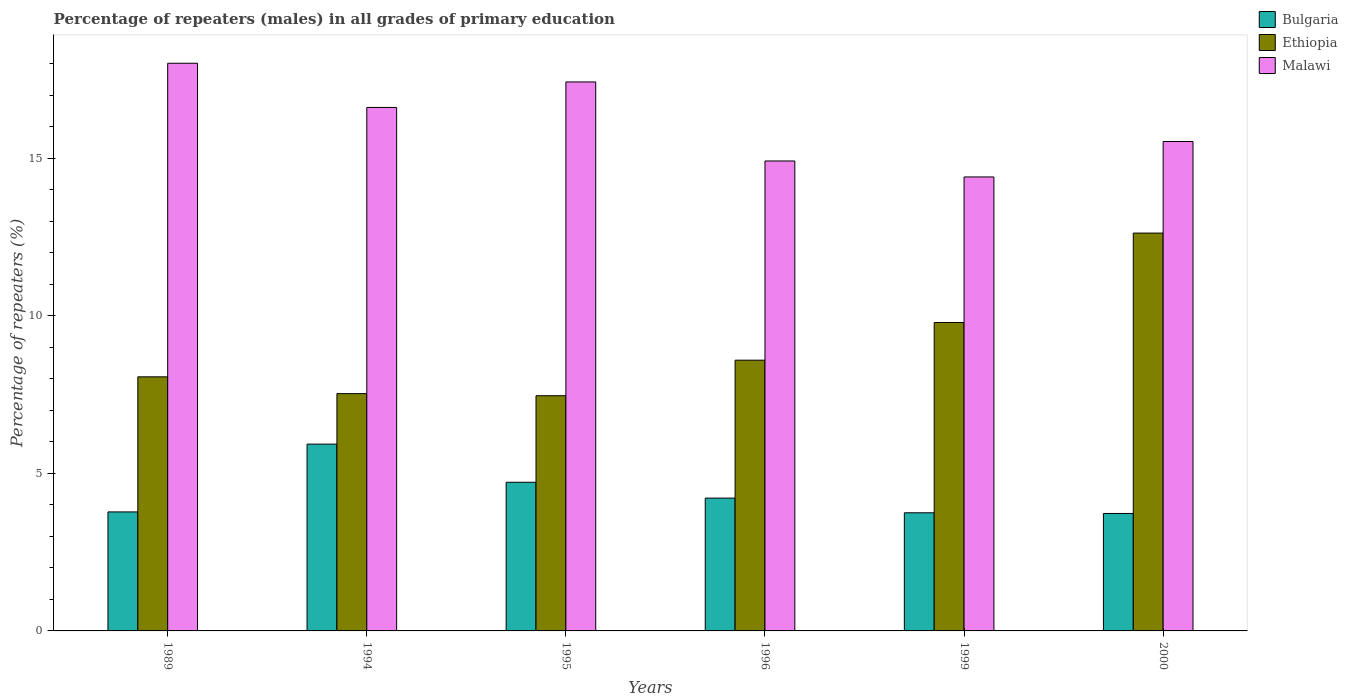Are the number of bars on each tick of the X-axis equal?
Offer a terse response. Yes. How many bars are there on the 1st tick from the right?
Keep it short and to the point. 3. What is the label of the 5th group of bars from the left?
Ensure brevity in your answer.  1999. In how many cases, is the number of bars for a given year not equal to the number of legend labels?
Ensure brevity in your answer.  0. What is the percentage of repeaters (males) in Bulgaria in 1996?
Offer a very short reply. 4.22. Across all years, what is the maximum percentage of repeaters (males) in Bulgaria?
Ensure brevity in your answer.  5.93. Across all years, what is the minimum percentage of repeaters (males) in Bulgaria?
Keep it short and to the point. 3.73. In which year was the percentage of repeaters (males) in Malawi maximum?
Your response must be concise. 1989. In which year was the percentage of repeaters (males) in Ethiopia minimum?
Offer a very short reply. 1995. What is the total percentage of repeaters (males) in Ethiopia in the graph?
Provide a short and direct response. 54.07. What is the difference between the percentage of repeaters (males) in Malawi in 1995 and that in 2000?
Provide a short and direct response. 1.89. What is the difference between the percentage of repeaters (males) in Malawi in 1999 and the percentage of repeaters (males) in Bulgaria in 1994?
Your answer should be very brief. 8.48. What is the average percentage of repeaters (males) in Bulgaria per year?
Offer a very short reply. 4.35. In the year 1996, what is the difference between the percentage of repeaters (males) in Malawi and percentage of repeaters (males) in Bulgaria?
Offer a terse response. 10.7. In how many years, is the percentage of repeaters (males) in Malawi greater than 1 %?
Provide a succinct answer. 6. What is the ratio of the percentage of repeaters (males) in Ethiopia in 1996 to that in 1999?
Your answer should be compact. 0.88. Is the difference between the percentage of repeaters (males) in Malawi in 1989 and 2000 greater than the difference between the percentage of repeaters (males) in Bulgaria in 1989 and 2000?
Provide a succinct answer. Yes. What is the difference between the highest and the second highest percentage of repeaters (males) in Ethiopia?
Keep it short and to the point. 2.84. What is the difference between the highest and the lowest percentage of repeaters (males) in Malawi?
Keep it short and to the point. 3.61. In how many years, is the percentage of repeaters (males) in Malawi greater than the average percentage of repeaters (males) in Malawi taken over all years?
Ensure brevity in your answer.  3. Is the sum of the percentage of repeaters (males) in Ethiopia in 1989 and 1999 greater than the maximum percentage of repeaters (males) in Malawi across all years?
Give a very brief answer. No. What does the 3rd bar from the left in 1999 represents?
Your response must be concise. Malawi. What does the 3rd bar from the right in 1995 represents?
Offer a terse response. Bulgaria. How many bars are there?
Offer a terse response. 18. How many years are there in the graph?
Your answer should be very brief. 6. What is the difference between two consecutive major ticks on the Y-axis?
Your answer should be very brief. 5. Are the values on the major ticks of Y-axis written in scientific E-notation?
Provide a succinct answer. No. Does the graph contain grids?
Ensure brevity in your answer.  No. Where does the legend appear in the graph?
Provide a short and direct response. Top right. How are the legend labels stacked?
Provide a succinct answer. Vertical. What is the title of the graph?
Provide a succinct answer. Percentage of repeaters (males) in all grades of primary education. What is the label or title of the Y-axis?
Your answer should be very brief. Percentage of repeaters (%). What is the Percentage of repeaters (%) in Bulgaria in 1989?
Offer a very short reply. 3.78. What is the Percentage of repeaters (%) of Ethiopia in 1989?
Offer a very short reply. 8.07. What is the Percentage of repeaters (%) in Malawi in 1989?
Your answer should be compact. 18.02. What is the Percentage of repeaters (%) of Bulgaria in 1994?
Your answer should be compact. 5.93. What is the Percentage of repeaters (%) in Ethiopia in 1994?
Ensure brevity in your answer.  7.53. What is the Percentage of repeaters (%) in Malawi in 1994?
Your answer should be very brief. 16.62. What is the Percentage of repeaters (%) in Bulgaria in 1995?
Provide a short and direct response. 4.72. What is the Percentage of repeaters (%) in Ethiopia in 1995?
Ensure brevity in your answer.  7.47. What is the Percentage of repeaters (%) in Malawi in 1995?
Make the answer very short. 17.43. What is the Percentage of repeaters (%) of Bulgaria in 1996?
Keep it short and to the point. 4.22. What is the Percentage of repeaters (%) of Ethiopia in 1996?
Provide a succinct answer. 8.59. What is the Percentage of repeaters (%) of Malawi in 1996?
Offer a terse response. 14.92. What is the Percentage of repeaters (%) in Bulgaria in 1999?
Make the answer very short. 3.75. What is the Percentage of repeaters (%) of Ethiopia in 1999?
Keep it short and to the point. 9.79. What is the Percentage of repeaters (%) in Malawi in 1999?
Make the answer very short. 14.41. What is the Percentage of repeaters (%) in Bulgaria in 2000?
Your answer should be compact. 3.73. What is the Percentage of repeaters (%) of Ethiopia in 2000?
Keep it short and to the point. 12.63. What is the Percentage of repeaters (%) of Malawi in 2000?
Your response must be concise. 15.53. Across all years, what is the maximum Percentage of repeaters (%) in Bulgaria?
Provide a short and direct response. 5.93. Across all years, what is the maximum Percentage of repeaters (%) in Ethiopia?
Provide a succinct answer. 12.63. Across all years, what is the maximum Percentage of repeaters (%) of Malawi?
Provide a succinct answer. 18.02. Across all years, what is the minimum Percentage of repeaters (%) in Bulgaria?
Ensure brevity in your answer.  3.73. Across all years, what is the minimum Percentage of repeaters (%) in Ethiopia?
Give a very brief answer. 7.47. Across all years, what is the minimum Percentage of repeaters (%) of Malawi?
Keep it short and to the point. 14.41. What is the total Percentage of repeaters (%) of Bulgaria in the graph?
Offer a terse response. 26.12. What is the total Percentage of repeaters (%) in Ethiopia in the graph?
Provide a succinct answer. 54.07. What is the total Percentage of repeaters (%) in Malawi in the graph?
Provide a short and direct response. 96.92. What is the difference between the Percentage of repeaters (%) in Bulgaria in 1989 and that in 1994?
Give a very brief answer. -2.15. What is the difference between the Percentage of repeaters (%) of Ethiopia in 1989 and that in 1994?
Your answer should be compact. 0.53. What is the difference between the Percentage of repeaters (%) in Malawi in 1989 and that in 1994?
Offer a terse response. 1.4. What is the difference between the Percentage of repeaters (%) of Bulgaria in 1989 and that in 1995?
Make the answer very short. -0.94. What is the difference between the Percentage of repeaters (%) of Ethiopia in 1989 and that in 1995?
Provide a succinct answer. 0.6. What is the difference between the Percentage of repeaters (%) of Malawi in 1989 and that in 1995?
Your response must be concise. 0.59. What is the difference between the Percentage of repeaters (%) in Bulgaria in 1989 and that in 1996?
Your answer should be very brief. -0.44. What is the difference between the Percentage of repeaters (%) of Ethiopia in 1989 and that in 1996?
Your answer should be very brief. -0.53. What is the difference between the Percentage of repeaters (%) in Malawi in 1989 and that in 1996?
Your answer should be compact. 3.1. What is the difference between the Percentage of repeaters (%) of Bulgaria in 1989 and that in 1999?
Give a very brief answer. 0.03. What is the difference between the Percentage of repeaters (%) of Ethiopia in 1989 and that in 1999?
Provide a succinct answer. -1.72. What is the difference between the Percentage of repeaters (%) of Malawi in 1989 and that in 1999?
Ensure brevity in your answer.  3.61. What is the difference between the Percentage of repeaters (%) of Bulgaria in 1989 and that in 2000?
Your response must be concise. 0.05. What is the difference between the Percentage of repeaters (%) of Ethiopia in 1989 and that in 2000?
Provide a succinct answer. -4.56. What is the difference between the Percentage of repeaters (%) of Malawi in 1989 and that in 2000?
Offer a very short reply. 2.48. What is the difference between the Percentage of repeaters (%) of Bulgaria in 1994 and that in 1995?
Keep it short and to the point. 1.21. What is the difference between the Percentage of repeaters (%) in Ethiopia in 1994 and that in 1995?
Give a very brief answer. 0.07. What is the difference between the Percentage of repeaters (%) of Malawi in 1994 and that in 1995?
Provide a succinct answer. -0.81. What is the difference between the Percentage of repeaters (%) of Bulgaria in 1994 and that in 1996?
Your response must be concise. 1.71. What is the difference between the Percentage of repeaters (%) of Ethiopia in 1994 and that in 1996?
Make the answer very short. -1.06. What is the difference between the Percentage of repeaters (%) of Malawi in 1994 and that in 1996?
Ensure brevity in your answer.  1.7. What is the difference between the Percentage of repeaters (%) in Bulgaria in 1994 and that in 1999?
Your answer should be compact. 2.18. What is the difference between the Percentage of repeaters (%) of Ethiopia in 1994 and that in 1999?
Make the answer very short. -2.26. What is the difference between the Percentage of repeaters (%) of Malawi in 1994 and that in 1999?
Your response must be concise. 2.21. What is the difference between the Percentage of repeaters (%) of Bulgaria in 1994 and that in 2000?
Offer a very short reply. 2.2. What is the difference between the Percentage of repeaters (%) in Ethiopia in 1994 and that in 2000?
Keep it short and to the point. -5.1. What is the difference between the Percentage of repeaters (%) in Malawi in 1994 and that in 2000?
Give a very brief answer. 1.08. What is the difference between the Percentage of repeaters (%) of Bulgaria in 1995 and that in 1996?
Keep it short and to the point. 0.5. What is the difference between the Percentage of repeaters (%) in Ethiopia in 1995 and that in 1996?
Provide a short and direct response. -1.13. What is the difference between the Percentage of repeaters (%) in Malawi in 1995 and that in 1996?
Provide a short and direct response. 2.51. What is the difference between the Percentage of repeaters (%) of Bulgaria in 1995 and that in 1999?
Provide a succinct answer. 0.97. What is the difference between the Percentage of repeaters (%) in Ethiopia in 1995 and that in 1999?
Offer a terse response. -2.32. What is the difference between the Percentage of repeaters (%) of Malawi in 1995 and that in 1999?
Your response must be concise. 3.02. What is the difference between the Percentage of repeaters (%) of Bulgaria in 1995 and that in 2000?
Make the answer very short. 0.99. What is the difference between the Percentage of repeaters (%) of Ethiopia in 1995 and that in 2000?
Your answer should be compact. -5.16. What is the difference between the Percentage of repeaters (%) in Malawi in 1995 and that in 2000?
Offer a terse response. 1.89. What is the difference between the Percentage of repeaters (%) of Bulgaria in 1996 and that in 1999?
Your answer should be very brief. 0.47. What is the difference between the Percentage of repeaters (%) of Ethiopia in 1996 and that in 1999?
Offer a terse response. -1.2. What is the difference between the Percentage of repeaters (%) in Malawi in 1996 and that in 1999?
Your answer should be very brief. 0.51. What is the difference between the Percentage of repeaters (%) of Bulgaria in 1996 and that in 2000?
Your answer should be very brief. 0.49. What is the difference between the Percentage of repeaters (%) of Ethiopia in 1996 and that in 2000?
Provide a short and direct response. -4.03. What is the difference between the Percentage of repeaters (%) of Malawi in 1996 and that in 2000?
Make the answer very short. -0.62. What is the difference between the Percentage of repeaters (%) of Bulgaria in 1999 and that in 2000?
Your response must be concise. 0.02. What is the difference between the Percentage of repeaters (%) in Ethiopia in 1999 and that in 2000?
Offer a very short reply. -2.84. What is the difference between the Percentage of repeaters (%) of Malawi in 1999 and that in 2000?
Give a very brief answer. -1.12. What is the difference between the Percentage of repeaters (%) of Bulgaria in 1989 and the Percentage of repeaters (%) of Ethiopia in 1994?
Your answer should be very brief. -3.75. What is the difference between the Percentage of repeaters (%) of Bulgaria in 1989 and the Percentage of repeaters (%) of Malawi in 1994?
Make the answer very short. -12.84. What is the difference between the Percentage of repeaters (%) in Ethiopia in 1989 and the Percentage of repeaters (%) in Malawi in 1994?
Keep it short and to the point. -8.55. What is the difference between the Percentage of repeaters (%) of Bulgaria in 1989 and the Percentage of repeaters (%) of Ethiopia in 1995?
Provide a short and direct response. -3.69. What is the difference between the Percentage of repeaters (%) of Bulgaria in 1989 and the Percentage of repeaters (%) of Malawi in 1995?
Offer a very short reply. -13.65. What is the difference between the Percentage of repeaters (%) of Ethiopia in 1989 and the Percentage of repeaters (%) of Malawi in 1995?
Give a very brief answer. -9.36. What is the difference between the Percentage of repeaters (%) in Bulgaria in 1989 and the Percentage of repeaters (%) in Ethiopia in 1996?
Provide a short and direct response. -4.82. What is the difference between the Percentage of repeaters (%) in Bulgaria in 1989 and the Percentage of repeaters (%) in Malawi in 1996?
Provide a short and direct response. -11.14. What is the difference between the Percentage of repeaters (%) of Ethiopia in 1989 and the Percentage of repeaters (%) of Malawi in 1996?
Offer a very short reply. -6.85. What is the difference between the Percentage of repeaters (%) in Bulgaria in 1989 and the Percentage of repeaters (%) in Ethiopia in 1999?
Offer a terse response. -6.01. What is the difference between the Percentage of repeaters (%) in Bulgaria in 1989 and the Percentage of repeaters (%) in Malawi in 1999?
Give a very brief answer. -10.63. What is the difference between the Percentage of repeaters (%) in Ethiopia in 1989 and the Percentage of repeaters (%) in Malawi in 1999?
Ensure brevity in your answer.  -6.34. What is the difference between the Percentage of repeaters (%) of Bulgaria in 1989 and the Percentage of repeaters (%) of Ethiopia in 2000?
Offer a terse response. -8.85. What is the difference between the Percentage of repeaters (%) in Bulgaria in 1989 and the Percentage of repeaters (%) in Malawi in 2000?
Offer a terse response. -11.76. What is the difference between the Percentage of repeaters (%) in Ethiopia in 1989 and the Percentage of repeaters (%) in Malawi in 2000?
Offer a terse response. -7.47. What is the difference between the Percentage of repeaters (%) of Bulgaria in 1994 and the Percentage of repeaters (%) of Ethiopia in 1995?
Provide a short and direct response. -1.54. What is the difference between the Percentage of repeaters (%) of Bulgaria in 1994 and the Percentage of repeaters (%) of Malawi in 1995?
Give a very brief answer. -11.5. What is the difference between the Percentage of repeaters (%) of Ethiopia in 1994 and the Percentage of repeaters (%) of Malawi in 1995?
Provide a short and direct response. -9.89. What is the difference between the Percentage of repeaters (%) in Bulgaria in 1994 and the Percentage of repeaters (%) in Ethiopia in 1996?
Your answer should be very brief. -2.66. What is the difference between the Percentage of repeaters (%) of Bulgaria in 1994 and the Percentage of repeaters (%) of Malawi in 1996?
Your response must be concise. -8.99. What is the difference between the Percentage of repeaters (%) in Ethiopia in 1994 and the Percentage of repeaters (%) in Malawi in 1996?
Offer a very short reply. -7.38. What is the difference between the Percentage of repeaters (%) of Bulgaria in 1994 and the Percentage of repeaters (%) of Ethiopia in 1999?
Offer a terse response. -3.86. What is the difference between the Percentage of repeaters (%) in Bulgaria in 1994 and the Percentage of repeaters (%) in Malawi in 1999?
Provide a succinct answer. -8.48. What is the difference between the Percentage of repeaters (%) of Ethiopia in 1994 and the Percentage of repeaters (%) of Malawi in 1999?
Keep it short and to the point. -6.88. What is the difference between the Percentage of repeaters (%) in Bulgaria in 1994 and the Percentage of repeaters (%) in Ethiopia in 2000?
Provide a short and direct response. -6.7. What is the difference between the Percentage of repeaters (%) of Bulgaria in 1994 and the Percentage of repeaters (%) of Malawi in 2000?
Offer a terse response. -9.61. What is the difference between the Percentage of repeaters (%) of Ethiopia in 1994 and the Percentage of repeaters (%) of Malawi in 2000?
Provide a succinct answer. -8. What is the difference between the Percentage of repeaters (%) in Bulgaria in 1995 and the Percentage of repeaters (%) in Ethiopia in 1996?
Your answer should be very brief. -3.87. What is the difference between the Percentage of repeaters (%) of Bulgaria in 1995 and the Percentage of repeaters (%) of Malawi in 1996?
Give a very brief answer. -10.2. What is the difference between the Percentage of repeaters (%) of Ethiopia in 1995 and the Percentage of repeaters (%) of Malawi in 1996?
Give a very brief answer. -7.45. What is the difference between the Percentage of repeaters (%) in Bulgaria in 1995 and the Percentage of repeaters (%) in Ethiopia in 1999?
Offer a terse response. -5.07. What is the difference between the Percentage of repeaters (%) in Bulgaria in 1995 and the Percentage of repeaters (%) in Malawi in 1999?
Your response must be concise. -9.69. What is the difference between the Percentage of repeaters (%) of Ethiopia in 1995 and the Percentage of repeaters (%) of Malawi in 1999?
Give a very brief answer. -6.94. What is the difference between the Percentage of repeaters (%) in Bulgaria in 1995 and the Percentage of repeaters (%) in Ethiopia in 2000?
Ensure brevity in your answer.  -7.91. What is the difference between the Percentage of repeaters (%) of Bulgaria in 1995 and the Percentage of repeaters (%) of Malawi in 2000?
Give a very brief answer. -10.82. What is the difference between the Percentage of repeaters (%) in Ethiopia in 1995 and the Percentage of repeaters (%) in Malawi in 2000?
Your answer should be compact. -8.07. What is the difference between the Percentage of repeaters (%) of Bulgaria in 1996 and the Percentage of repeaters (%) of Ethiopia in 1999?
Give a very brief answer. -5.57. What is the difference between the Percentage of repeaters (%) in Bulgaria in 1996 and the Percentage of repeaters (%) in Malawi in 1999?
Ensure brevity in your answer.  -10.19. What is the difference between the Percentage of repeaters (%) of Ethiopia in 1996 and the Percentage of repeaters (%) of Malawi in 1999?
Offer a terse response. -5.82. What is the difference between the Percentage of repeaters (%) in Bulgaria in 1996 and the Percentage of repeaters (%) in Ethiopia in 2000?
Keep it short and to the point. -8.41. What is the difference between the Percentage of repeaters (%) in Bulgaria in 1996 and the Percentage of repeaters (%) in Malawi in 2000?
Make the answer very short. -11.32. What is the difference between the Percentage of repeaters (%) in Ethiopia in 1996 and the Percentage of repeaters (%) in Malawi in 2000?
Provide a succinct answer. -6.94. What is the difference between the Percentage of repeaters (%) in Bulgaria in 1999 and the Percentage of repeaters (%) in Ethiopia in 2000?
Your response must be concise. -8.88. What is the difference between the Percentage of repeaters (%) in Bulgaria in 1999 and the Percentage of repeaters (%) in Malawi in 2000?
Provide a succinct answer. -11.78. What is the difference between the Percentage of repeaters (%) in Ethiopia in 1999 and the Percentage of repeaters (%) in Malawi in 2000?
Your response must be concise. -5.75. What is the average Percentage of repeaters (%) in Bulgaria per year?
Ensure brevity in your answer.  4.35. What is the average Percentage of repeaters (%) in Ethiopia per year?
Provide a succinct answer. 9.01. What is the average Percentage of repeaters (%) of Malawi per year?
Offer a terse response. 16.15. In the year 1989, what is the difference between the Percentage of repeaters (%) of Bulgaria and Percentage of repeaters (%) of Ethiopia?
Offer a terse response. -4.29. In the year 1989, what is the difference between the Percentage of repeaters (%) in Bulgaria and Percentage of repeaters (%) in Malawi?
Provide a succinct answer. -14.24. In the year 1989, what is the difference between the Percentage of repeaters (%) of Ethiopia and Percentage of repeaters (%) of Malawi?
Give a very brief answer. -9.95. In the year 1994, what is the difference between the Percentage of repeaters (%) in Bulgaria and Percentage of repeaters (%) in Ethiopia?
Your response must be concise. -1.6. In the year 1994, what is the difference between the Percentage of repeaters (%) in Bulgaria and Percentage of repeaters (%) in Malawi?
Your answer should be very brief. -10.69. In the year 1994, what is the difference between the Percentage of repeaters (%) of Ethiopia and Percentage of repeaters (%) of Malawi?
Your answer should be compact. -9.08. In the year 1995, what is the difference between the Percentage of repeaters (%) of Bulgaria and Percentage of repeaters (%) of Ethiopia?
Your response must be concise. -2.75. In the year 1995, what is the difference between the Percentage of repeaters (%) of Bulgaria and Percentage of repeaters (%) of Malawi?
Keep it short and to the point. -12.71. In the year 1995, what is the difference between the Percentage of repeaters (%) of Ethiopia and Percentage of repeaters (%) of Malawi?
Ensure brevity in your answer.  -9.96. In the year 1996, what is the difference between the Percentage of repeaters (%) of Bulgaria and Percentage of repeaters (%) of Ethiopia?
Make the answer very short. -4.38. In the year 1996, what is the difference between the Percentage of repeaters (%) of Bulgaria and Percentage of repeaters (%) of Malawi?
Your answer should be compact. -10.7. In the year 1996, what is the difference between the Percentage of repeaters (%) in Ethiopia and Percentage of repeaters (%) in Malawi?
Keep it short and to the point. -6.32. In the year 1999, what is the difference between the Percentage of repeaters (%) of Bulgaria and Percentage of repeaters (%) of Ethiopia?
Offer a terse response. -6.04. In the year 1999, what is the difference between the Percentage of repeaters (%) of Bulgaria and Percentage of repeaters (%) of Malawi?
Your answer should be compact. -10.66. In the year 1999, what is the difference between the Percentage of repeaters (%) in Ethiopia and Percentage of repeaters (%) in Malawi?
Your response must be concise. -4.62. In the year 2000, what is the difference between the Percentage of repeaters (%) in Bulgaria and Percentage of repeaters (%) in Ethiopia?
Offer a terse response. -8.9. In the year 2000, what is the difference between the Percentage of repeaters (%) in Bulgaria and Percentage of repeaters (%) in Malawi?
Offer a terse response. -11.81. In the year 2000, what is the difference between the Percentage of repeaters (%) of Ethiopia and Percentage of repeaters (%) of Malawi?
Provide a short and direct response. -2.91. What is the ratio of the Percentage of repeaters (%) in Bulgaria in 1989 to that in 1994?
Your response must be concise. 0.64. What is the ratio of the Percentage of repeaters (%) in Ethiopia in 1989 to that in 1994?
Your answer should be compact. 1.07. What is the ratio of the Percentage of repeaters (%) of Malawi in 1989 to that in 1994?
Provide a short and direct response. 1.08. What is the ratio of the Percentage of repeaters (%) of Bulgaria in 1989 to that in 1995?
Your answer should be very brief. 0.8. What is the ratio of the Percentage of repeaters (%) of Ethiopia in 1989 to that in 1995?
Provide a short and direct response. 1.08. What is the ratio of the Percentage of repeaters (%) of Malawi in 1989 to that in 1995?
Make the answer very short. 1.03. What is the ratio of the Percentage of repeaters (%) of Bulgaria in 1989 to that in 1996?
Give a very brief answer. 0.9. What is the ratio of the Percentage of repeaters (%) of Ethiopia in 1989 to that in 1996?
Give a very brief answer. 0.94. What is the ratio of the Percentage of repeaters (%) in Malawi in 1989 to that in 1996?
Ensure brevity in your answer.  1.21. What is the ratio of the Percentage of repeaters (%) of Bulgaria in 1989 to that in 1999?
Keep it short and to the point. 1.01. What is the ratio of the Percentage of repeaters (%) of Ethiopia in 1989 to that in 1999?
Ensure brevity in your answer.  0.82. What is the ratio of the Percentage of repeaters (%) in Malawi in 1989 to that in 1999?
Provide a short and direct response. 1.25. What is the ratio of the Percentage of repeaters (%) of Bulgaria in 1989 to that in 2000?
Keep it short and to the point. 1.01. What is the ratio of the Percentage of repeaters (%) of Ethiopia in 1989 to that in 2000?
Give a very brief answer. 0.64. What is the ratio of the Percentage of repeaters (%) of Malawi in 1989 to that in 2000?
Give a very brief answer. 1.16. What is the ratio of the Percentage of repeaters (%) of Bulgaria in 1994 to that in 1995?
Provide a short and direct response. 1.26. What is the ratio of the Percentage of repeaters (%) in Ethiopia in 1994 to that in 1995?
Provide a succinct answer. 1.01. What is the ratio of the Percentage of repeaters (%) of Malawi in 1994 to that in 1995?
Offer a very short reply. 0.95. What is the ratio of the Percentage of repeaters (%) in Bulgaria in 1994 to that in 1996?
Your answer should be compact. 1.41. What is the ratio of the Percentage of repeaters (%) in Ethiopia in 1994 to that in 1996?
Offer a very short reply. 0.88. What is the ratio of the Percentage of repeaters (%) of Malawi in 1994 to that in 1996?
Provide a short and direct response. 1.11. What is the ratio of the Percentage of repeaters (%) of Bulgaria in 1994 to that in 1999?
Provide a short and direct response. 1.58. What is the ratio of the Percentage of repeaters (%) of Ethiopia in 1994 to that in 1999?
Offer a terse response. 0.77. What is the ratio of the Percentage of repeaters (%) in Malawi in 1994 to that in 1999?
Your answer should be very brief. 1.15. What is the ratio of the Percentage of repeaters (%) in Bulgaria in 1994 to that in 2000?
Keep it short and to the point. 1.59. What is the ratio of the Percentage of repeaters (%) of Ethiopia in 1994 to that in 2000?
Your answer should be compact. 0.6. What is the ratio of the Percentage of repeaters (%) of Malawi in 1994 to that in 2000?
Make the answer very short. 1.07. What is the ratio of the Percentage of repeaters (%) in Bulgaria in 1995 to that in 1996?
Your answer should be very brief. 1.12. What is the ratio of the Percentage of repeaters (%) in Ethiopia in 1995 to that in 1996?
Ensure brevity in your answer.  0.87. What is the ratio of the Percentage of repeaters (%) in Malawi in 1995 to that in 1996?
Ensure brevity in your answer.  1.17. What is the ratio of the Percentage of repeaters (%) of Bulgaria in 1995 to that in 1999?
Give a very brief answer. 1.26. What is the ratio of the Percentage of repeaters (%) of Ethiopia in 1995 to that in 1999?
Your answer should be very brief. 0.76. What is the ratio of the Percentage of repeaters (%) in Malawi in 1995 to that in 1999?
Your answer should be compact. 1.21. What is the ratio of the Percentage of repeaters (%) of Bulgaria in 1995 to that in 2000?
Give a very brief answer. 1.27. What is the ratio of the Percentage of repeaters (%) in Ethiopia in 1995 to that in 2000?
Offer a terse response. 0.59. What is the ratio of the Percentage of repeaters (%) of Malawi in 1995 to that in 2000?
Your response must be concise. 1.12. What is the ratio of the Percentage of repeaters (%) in Bulgaria in 1996 to that in 1999?
Keep it short and to the point. 1.12. What is the ratio of the Percentage of repeaters (%) in Ethiopia in 1996 to that in 1999?
Offer a very short reply. 0.88. What is the ratio of the Percentage of repeaters (%) of Malawi in 1996 to that in 1999?
Make the answer very short. 1.04. What is the ratio of the Percentage of repeaters (%) of Bulgaria in 1996 to that in 2000?
Your answer should be very brief. 1.13. What is the ratio of the Percentage of repeaters (%) in Ethiopia in 1996 to that in 2000?
Provide a short and direct response. 0.68. What is the ratio of the Percentage of repeaters (%) in Malawi in 1996 to that in 2000?
Your answer should be very brief. 0.96. What is the ratio of the Percentage of repeaters (%) of Bulgaria in 1999 to that in 2000?
Your response must be concise. 1.01. What is the ratio of the Percentage of repeaters (%) in Ethiopia in 1999 to that in 2000?
Your response must be concise. 0.78. What is the ratio of the Percentage of repeaters (%) in Malawi in 1999 to that in 2000?
Your response must be concise. 0.93. What is the difference between the highest and the second highest Percentage of repeaters (%) of Bulgaria?
Give a very brief answer. 1.21. What is the difference between the highest and the second highest Percentage of repeaters (%) of Ethiopia?
Keep it short and to the point. 2.84. What is the difference between the highest and the second highest Percentage of repeaters (%) in Malawi?
Offer a terse response. 0.59. What is the difference between the highest and the lowest Percentage of repeaters (%) in Bulgaria?
Provide a short and direct response. 2.2. What is the difference between the highest and the lowest Percentage of repeaters (%) in Ethiopia?
Provide a succinct answer. 5.16. What is the difference between the highest and the lowest Percentage of repeaters (%) in Malawi?
Keep it short and to the point. 3.61. 